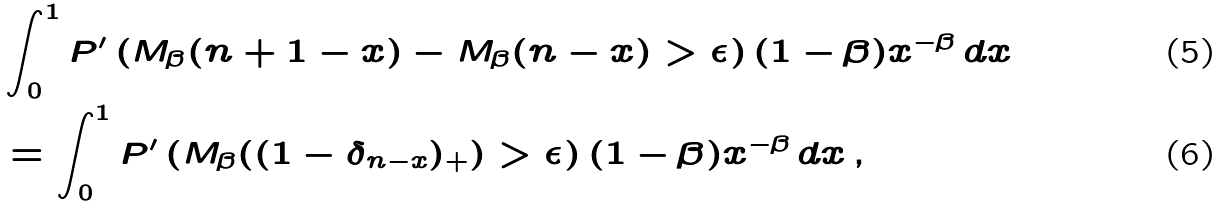<formula> <loc_0><loc_0><loc_500><loc_500>& \int _ { 0 } ^ { 1 } P ^ { \prime } \left ( M _ { \beta } ( n + 1 - x ) - M _ { \beta } ( n - x ) > \epsilon \right ) ( 1 - \beta ) x ^ { - \beta } \, d x \\ & = \int _ { 0 } ^ { 1 } P ^ { \prime } \left ( M _ { \beta } ( ( 1 - \delta _ { n - x } ) _ { + } ) > \epsilon \right ) ( 1 - \beta ) x ^ { - \beta } \, d x \, ,</formula> 